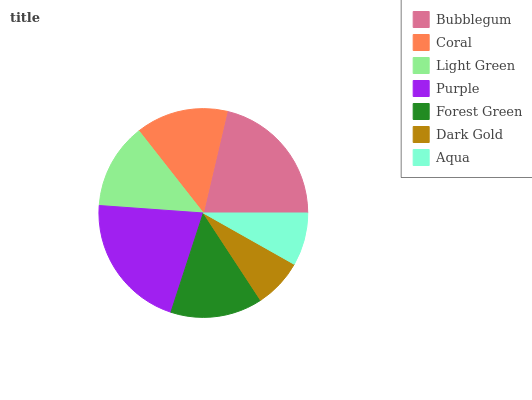Is Dark Gold the minimum?
Answer yes or no. Yes. Is Bubblegum the maximum?
Answer yes or no. Yes. Is Coral the minimum?
Answer yes or no. No. Is Coral the maximum?
Answer yes or no. No. Is Bubblegum greater than Coral?
Answer yes or no. Yes. Is Coral less than Bubblegum?
Answer yes or no. Yes. Is Coral greater than Bubblegum?
Answer yes or no. No. Is Bubblegum less than Coral?
Answer yes or no. No. Is Forest Green the high median?
Answer yes or no. Yes. Is Forest Green the low median?
Answer yes or no. Yes. Is Purple the high median?
Answer yes or no. No. Is Bubblegum the low median?
Answer yes or no. No. 